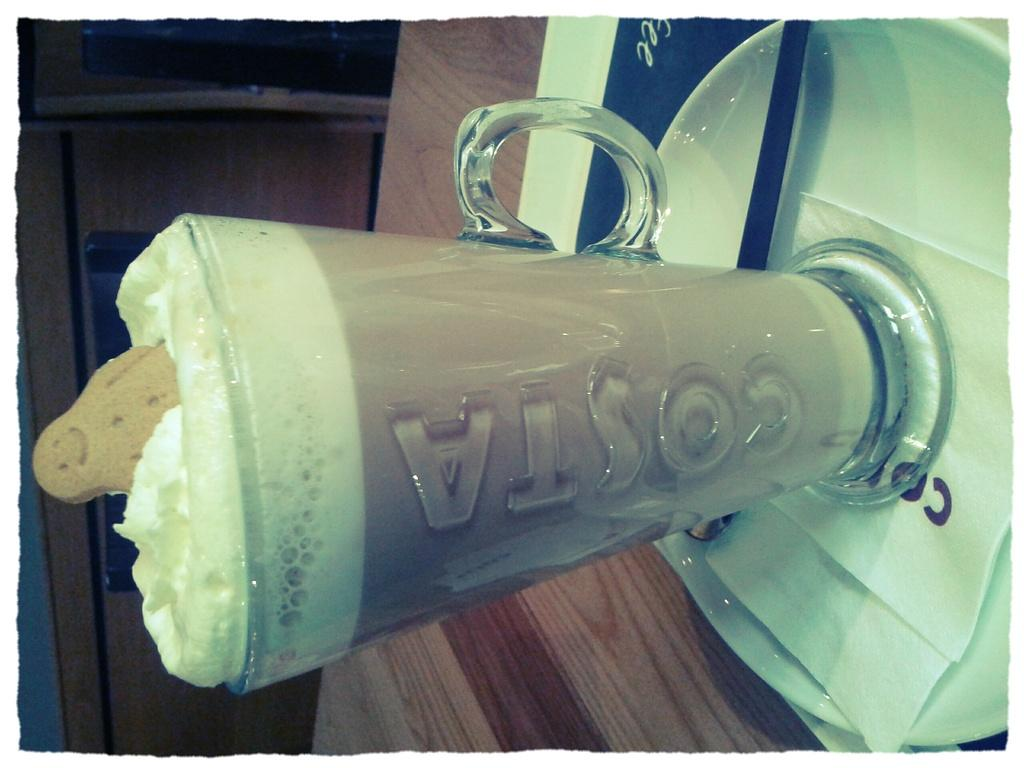What is the main object in the center of the image? There is a table in the center of the image. What is placed on the table? There is a plate, a paper, and a glass of milkshake on the table. What might be used for holding a beverage in the image? The glass of milkshake is present for holding a beverage. How many beds can be seen in the image? There are no beds present in the image. What is the purpose of the stop sign in the image? There is no stop sign present in the image. 